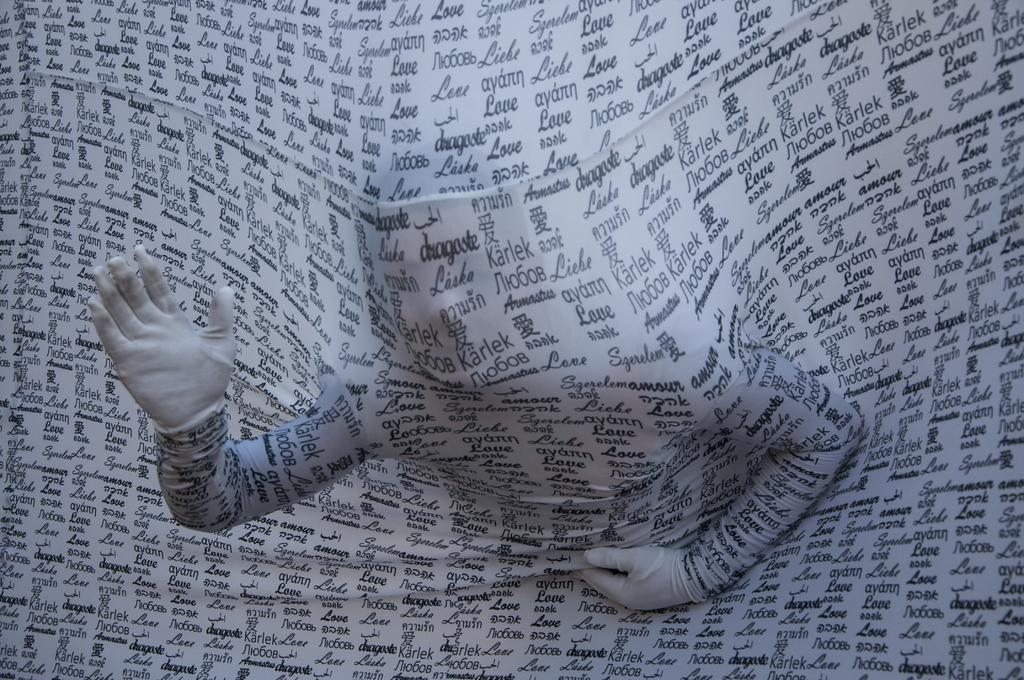What is present on the cloth in the image? There is text on the cloth in the image. What is the person in the image doing? The person is bending forward in the image. What type of stamp can be seen on the committee list in the image? There is no stamp or committee list present in the image. What items are on the list that the person is holding in the image? There is no list present in the image, as the person is not holding anything. 